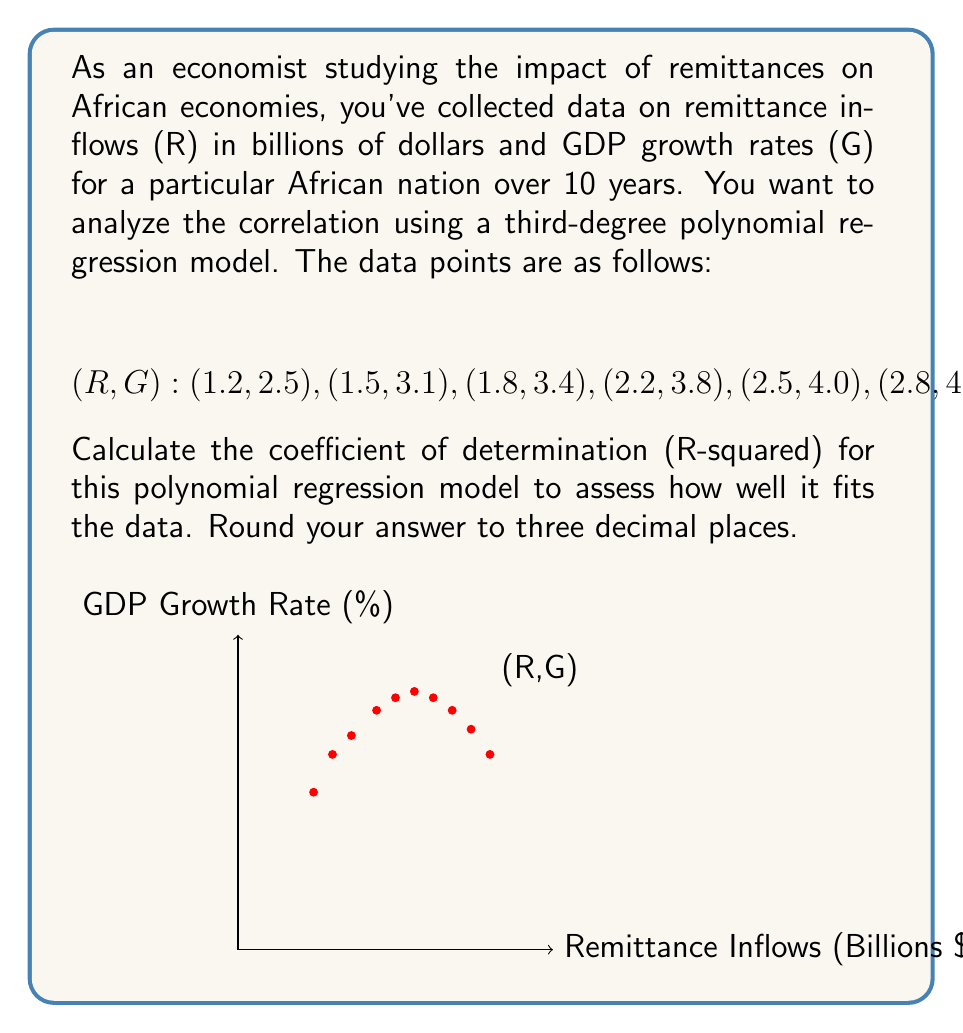Can you solve this math problem? To calculate the coefficient of determination (R-squared) for a third-degree polynomial regression, we need to follow these steps:

1) First, we need to find the coefficients of the polynomial regression equation:
   $$G = a + bR + cR^2 + dR^3$$

   Using a statistical software or calculator, we get:
   $$G = -0.8929 + 4.7321R - 1.5179R^2 + 0.1488R^3$$

2) Calculate the predicted G values (Ĝ) using this equation for each R value.

3) Calculate the total sum of squares (SST):
   $$SST = \sum_{i=1}^{n} (G_i - \bar{G})^2$$
   where $\bar{G}$ is the mean of all G values.

4) Calculate the residual sum of squares (SSR):
   $$SSR = \sum_{i=1}^{n} (G_i - \hat{G}_i)^2$$

5) Calculate R-squared:
   $$R^2 = 1 - \frac{SSR}{SST}$$

Let's perform these calculations:

$\bar{G} = 3.53$

SST calculation:
$SST = (2.5-3.53)^2 + (3.1-3.53)^2 + ... + (3.1-3.53)^2 = 3.2441$

SSR calculation:
First, we calculate Ĝ for each R:
$\hat{G}_1 = -0.8929 + 4.7321(1.2) - 1.5179(1.2)^2 + 0.1488(1.2)^3 = 2.5034$
(Repeat for all R values)

Then:
$SSR = (2.5-2.5034)^2 + (3.1-3.0911)^2 + ... + (3.1-3.1027)^2 = 0.0111$

Finally:
$$R^2 = 1 - \frac{0.0111}{3.2441} = 0.9966$$

Rounded to three decimal places: 0.997
Answer: 0.997 